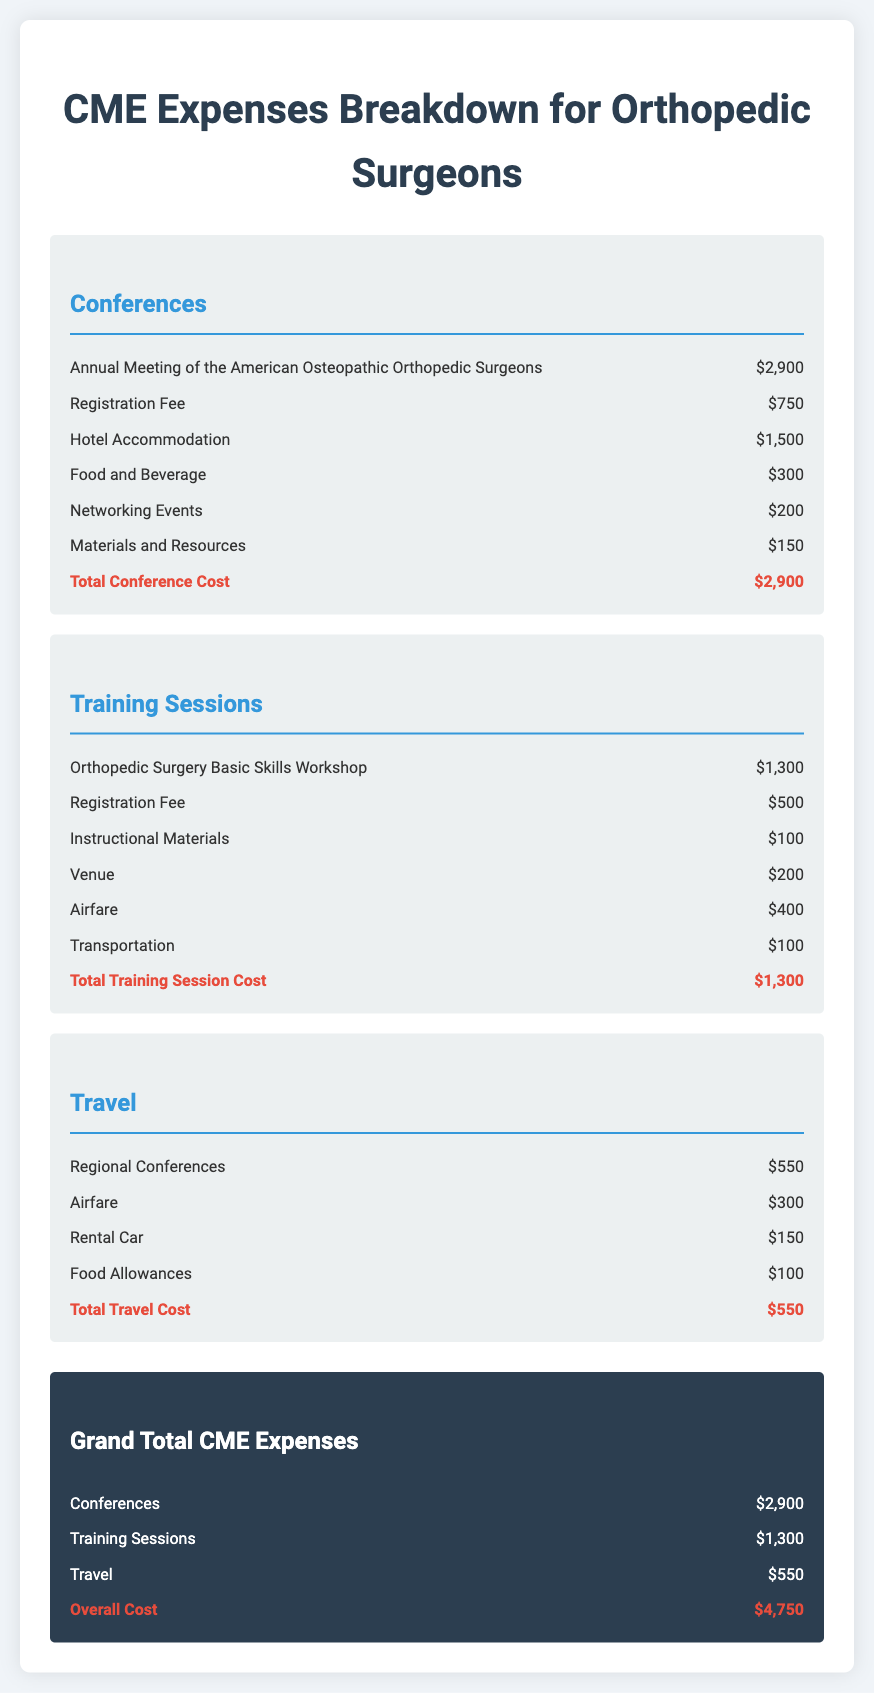What is the total cost for conferences? The total cost for conferences is listed in the document as the sum of all individual conference expenses, which equals $2,900.
Answer: $2,900 What is the registration fee for the training session? The registration fee for the training session is a specific expense that is detailed in the document under training sessions, which is $500.
Answer: $500 What is the airfare cost for the conferences? The airfare costs to attend conferences is not explicitly listed in the conference section; however, it is mentioned in the travel section.
Answer: Not specified How much is allocated for food and beverages during the conference? The document provides a specific amount set aside for food and beverages, which is $300.
Answer: $300 What is the grand total of CME expenses? The grand total is the sum of all categories listed in the document, including conferences, training sessions, and travel, which totals $4,750.
Answer: $4,750 What is the cost of networking events? The cost for networking events during the conferences is specifically outlined in the document as $200.
Answer: $200 What is the total cost for training sessions? The document sums up all expenses related to training sessions, which is mentioned as $1,300.
Answer: $1,300 How much is spent on rental cars under travel expenses? The rental car expenses specifically listed under travel amount to $150.
Answer: $150 What is the cost for hotel accommodation during the conference? Hotel accommodation costs are detailed in the conference section of the document, reflecting a total of $1,500.
Answer: $1,500 